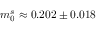Convert formula to latex. <formula><loc_0><loc_0><loc_500><loc_500>m _ { 0 } ^ { s } \approx 0 . 2 0 2 \pm 0 . 0 1 8</formula> 